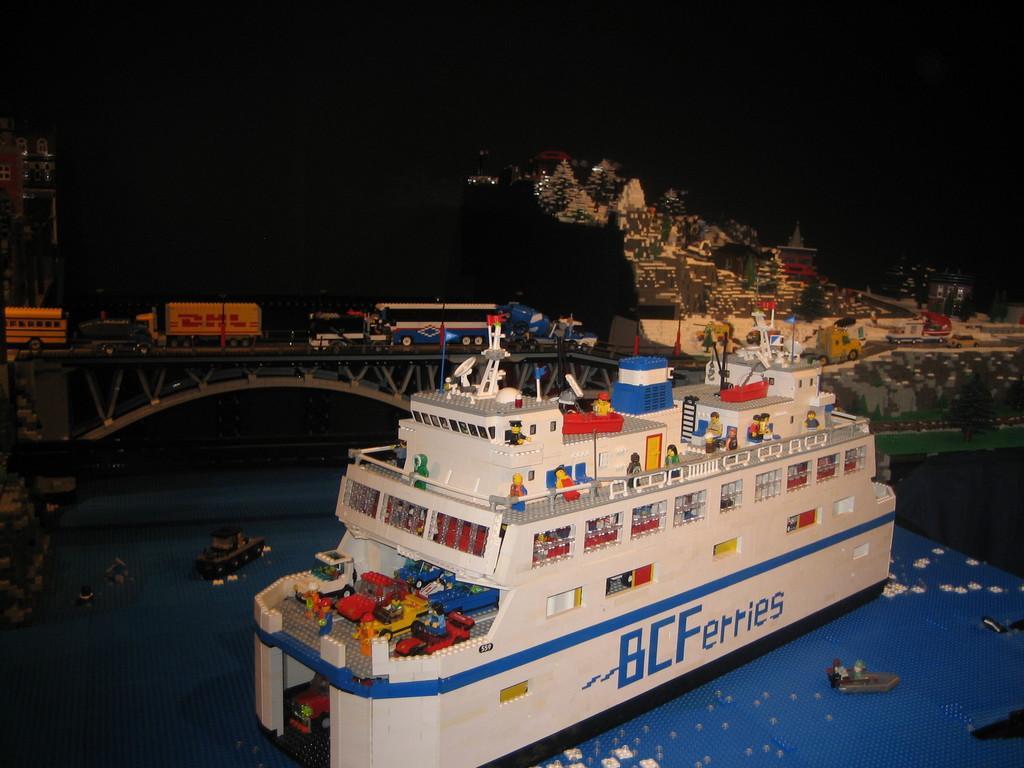Can you describe this image briefly? In this picture there is a design of a city. In the foreground there is a ship. In the center of the picture there are vehicles on the bridge. In the background there are buildings. At the bottom there are boats in the water. 